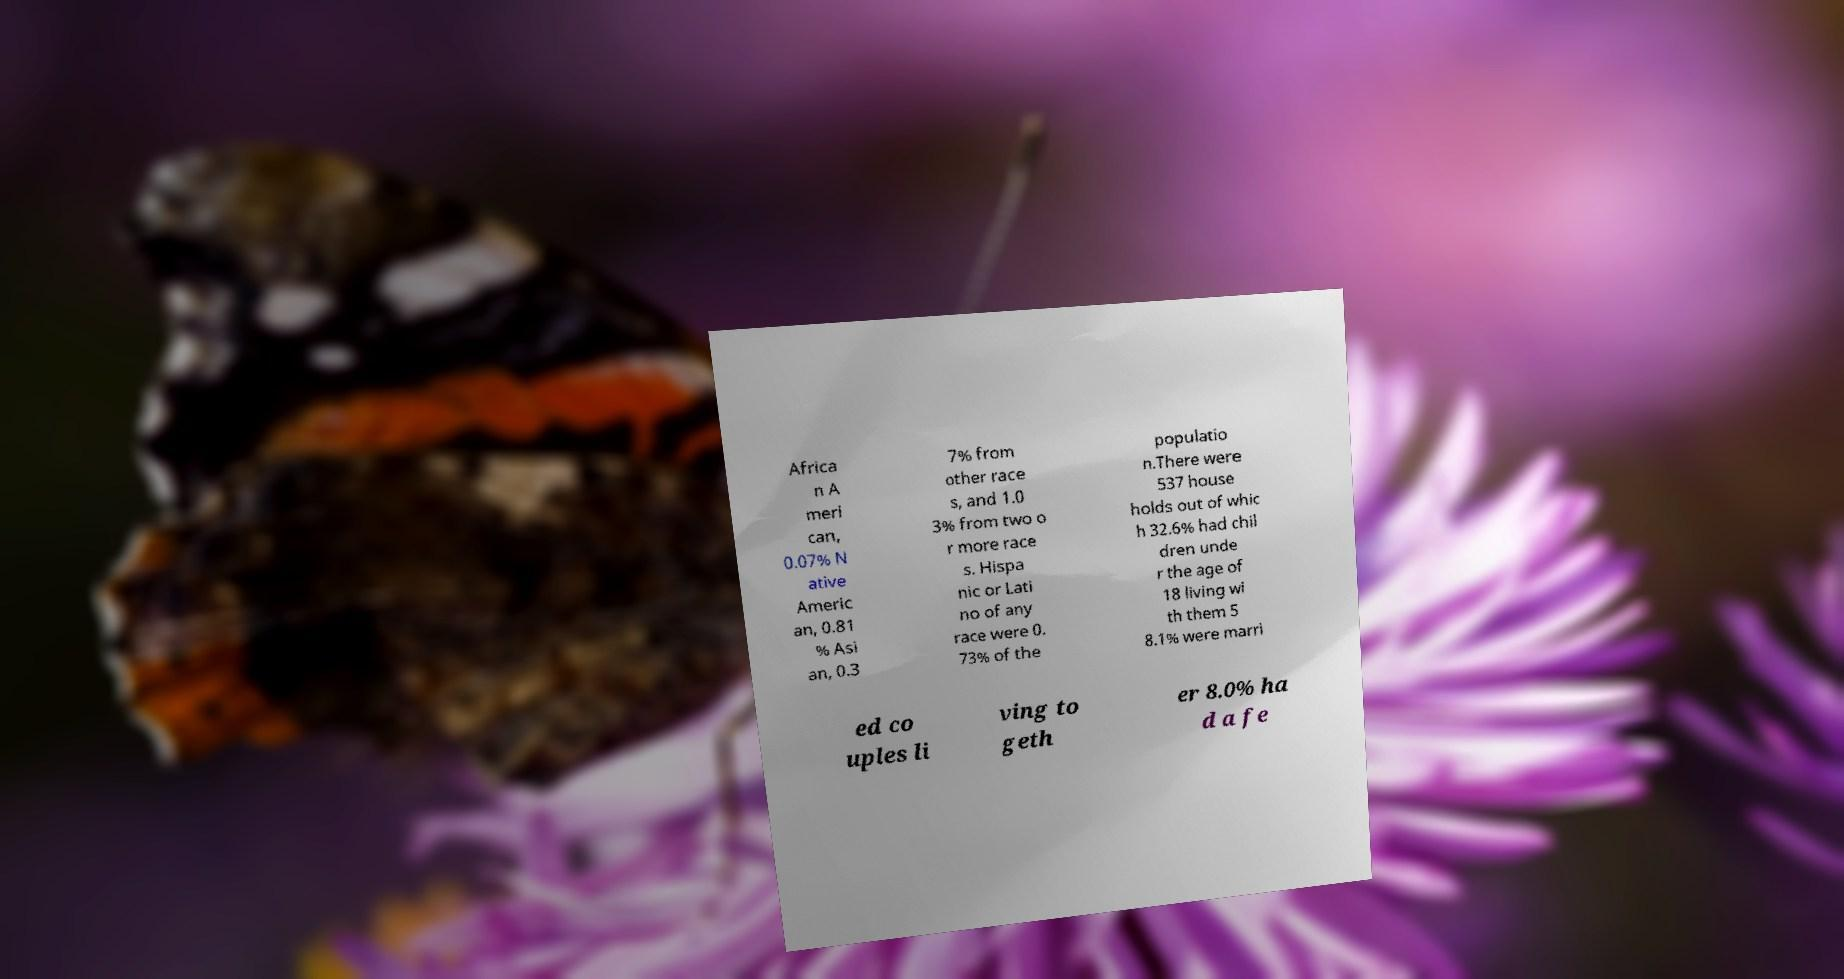Please identify and transcribe the text found in this image. Africa n A meri can, 0.07% N ative Americ an, 0.81 % Asi an, 0.3 7% from other race s, and 1.0 3% from two o r more race s. Hispa nic or Lati no of any race were 0. 73% of the populatio n.There were 537 house holds out of whic h 32.6% had chil dren unde r the age of 18 living wi th them 5 8.1% were marri ed co uples li ving to geth er 8.0% ha d a fe 